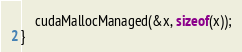<code> <loc_0><loc_0><loc_500><loc_500><_Cuda_>
	cudaMallocManaged(&x, sizeof(x));
}
</code> 